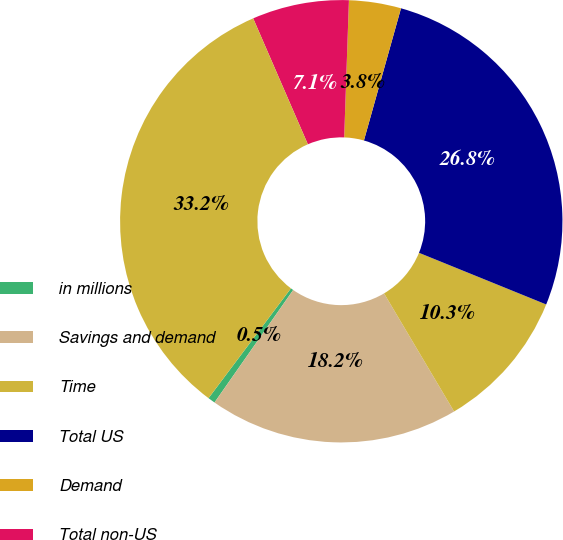<chart> <loc_0><loc_0><loc_500><loc_500><pie_chart><fcel>in millions<fcel>Savings and demand<fcel>Time<fcel>Total US<fcel>Demand<fcel>Total non-US<fcel>Total<nl><fcel>0.53%<fcel>18.23%<fcel>10.34%<fcel>26.78%<fcel>3.8%<fcel>7.07%<fcel>33.23%<nl></chart> 